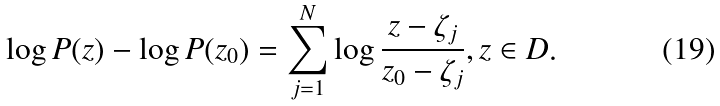<formula> <loc_0><loc_0><loc_500><loc_500>\log P ( z ) - \log P ( z _ { 0 } ) = \sum _ { j = 1 } ^ { N } \log \frac { z - \zeta _ { j } } { z _ { 0 } - \zeta _ { j } } , z \in D .</formula> 